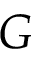Convert formula to latex. <formula><loc_0><loc_0><loc_500><loc_500>G</formula> 